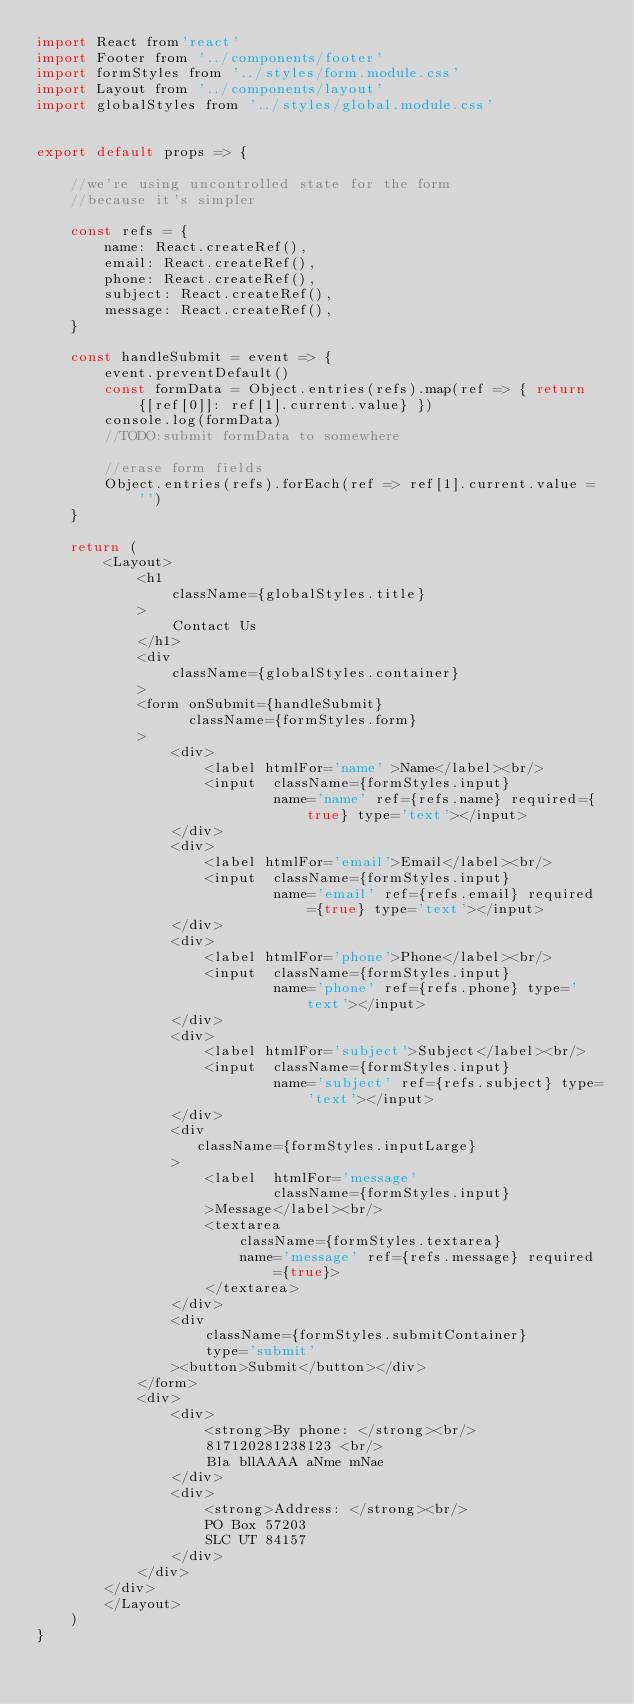<code> <loc_0><loc_0><loc_500><loc_500><_JavaScript_>import React from'react'
import Footer from '../components/footer'
import formStyles from '../styles/form.module.css'
import Layout from '../components/layout'
import globalStyles from '../styles/global.module.css'


export default props => {

    //we're using uncontrolled state for the form
    //because it's simpler

    const refs = {
        name: React.createRef(),
        email: React.createRef(),
        phone: React.createRef(),
        subject: React.createRef(),
        message: React.createRef(),
    }

    const handleSubmit = event => {
        event.preventDefault()
        const formData = Object.entries(refs).map(ref => { return {[ref[0]]: ref[1].current.value} })
        console.log(formData)
        //TODO:submit formData to somewhere
        
        //erase form fields
        Object.entries(refs).forEach(ref => ref[1].current.value = '')
    }
    
    return (
        <Layout>
            <h1 
                className={globalStyles.title} 
            >
                Contact Us
            </h1>
            <div
                className={globalStyles.container}
            >
            <form onSubmit={handleSubmit}
                  className={formStyles.form}  
            >
                <div>
                    <label htmlFor='name' >Name</label><br/>
                    <input  className={formStyles.input}
                            name='name' ref={refs.name} required={true} type='text'></input>
                </div>
                <div>
                    <label htmlFor='email'>Email</label><br/>
                    <input  className={formStyles.input}
                            name='email' ref={refs.email} required={true} type='text'></input>
                </div>
                <div>
                    <label htmlFor='phone'>Phone</label><br/>
                    <input  className={formStyles.input}
                            name='phone' ref={refs.phone} type='text'></input>
                </div>
                <div>
                    <label htmlFor='subject'>Subject</label><br/>
                    <input  className={formStyles.input}
                            name='subject' ref={refs.subject} type='text'></input>
                </div>
                <div
                   className={formStyles.inputLarge}
                >
                    <label  htmlFor='message'
                            className={formStyles.input}
                    >Message</label><br/>
                    <textarea 
                        className={formStyles.textarea}
                        name='message' ref={refs.message} required={true}>
                    </textarea>
                </div>
                <div 
                    className={formStyles.submitContainer}
                    type='submit'
                ><button>Submit</button></div>
            </form>
            <div>
                <div>
                    <strong>By phone: </strong><br/>
                    817120281238123 <br/>
                    Bla bllAAAA aNme mNae
                </div>
                <div>
                    <strong>Address: </strong><br/>
                    PO Box 57203
                    SLC UT 84157
                </div>
            </div>
        </div>
        </Layout>
    )
}</code> 